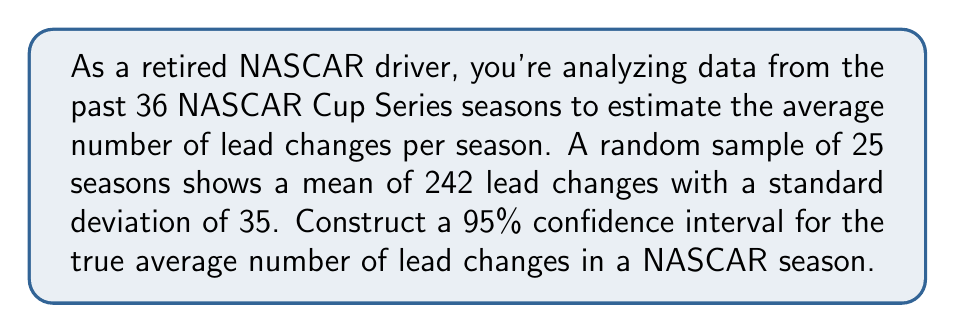What is the answer to this math problem? Let's approach this step-by-step:

1) We're dealing with a confidence interval for a population mean with unknown population standard deviation. We'll use the t-distribution.

2) Given information:
   - Sample size: $n = 25$
   - Sample mean: $\bar{x} = 242$
   - Sample standard deviation: $s = 35$
   - Confidence level: 95% (α = 0.05)

3) The formula for the confidence interval is:

   $$\bar{x} \pm t_{\alpha/2, n-1} \cdot \frac{s}{\sqrt{n}}$$

4) We need to find $t_{\alpha/2, n-1}$:
   - Degrees of freedom: $df = n - 1 = 24$
   - For a 95% confidence interval, $\alpha/2 = 0.025$
   - From t-table or calculator: $t_{0.025, 24} \approx 2.064$

5) Calculate the margin of error:

   $$\text{ME} = t_{\alpha/2, n-1} \cdot \frac{s}{\sqrt{n}} = 2.064 \cdot \frac{35}{\sqrt{25}} \approx 14.45$$

6) Now we can construct the confidence interval:

   $$242 \pm 14.45$$

7) Therefore, the 95% confidence interval is:

   $$(242 - 14.45, 242 + 14.45) = (227.55, 256.45)$$

We can be 95% confident that the true average number of lead changes in a NASCAR season falls between 227.55 and 256.45.
Answer: (227.55, 256.45) 